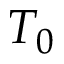<formula> <loc_0><loc_0><loc_500><loc_500>T _ { 0 }</formula> 